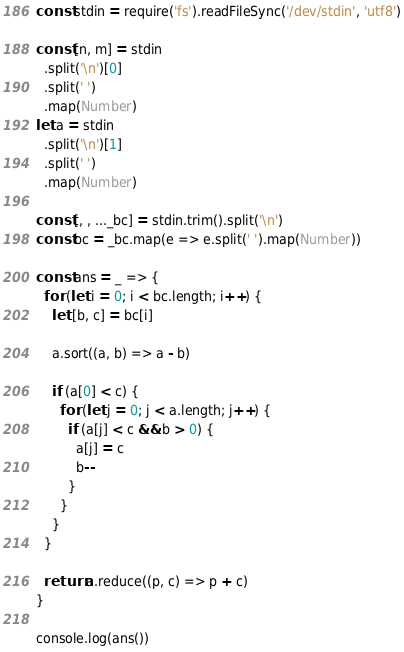Convert code to text. <code><loc_0><loc_0><loc_500><loc_500><_TypeScript_>const stdin = require('fs').readFileSync('/dev/stdin', 'utf8')

const [n, m] = stdin
  .split('\n')[0]
  .split(' ')
  .map(Number)
let a = stdin
  .split('\n')[1]
  .split(' ')
  .map(Number)

const [, , ..._bc] = stdin.trim().split('\n')
const bc = _bc.map(e => e.split(' ').map(Number))

const ans = _ => {
  for (let i = 0; i < bc.length; i++) {
    let [b, c] = bc[i]

    a.sort((a, b) => a - b)

    if (a[0] < c) {
      for (let j = 0; j < a.length; j++) {
        if (a[j] < c && b > 0) {
          a[j] = c
          b--
        }
      }
    }
  }

  return a.reduce((p, c) => p + c)
}

console.log(ans())
</code> 